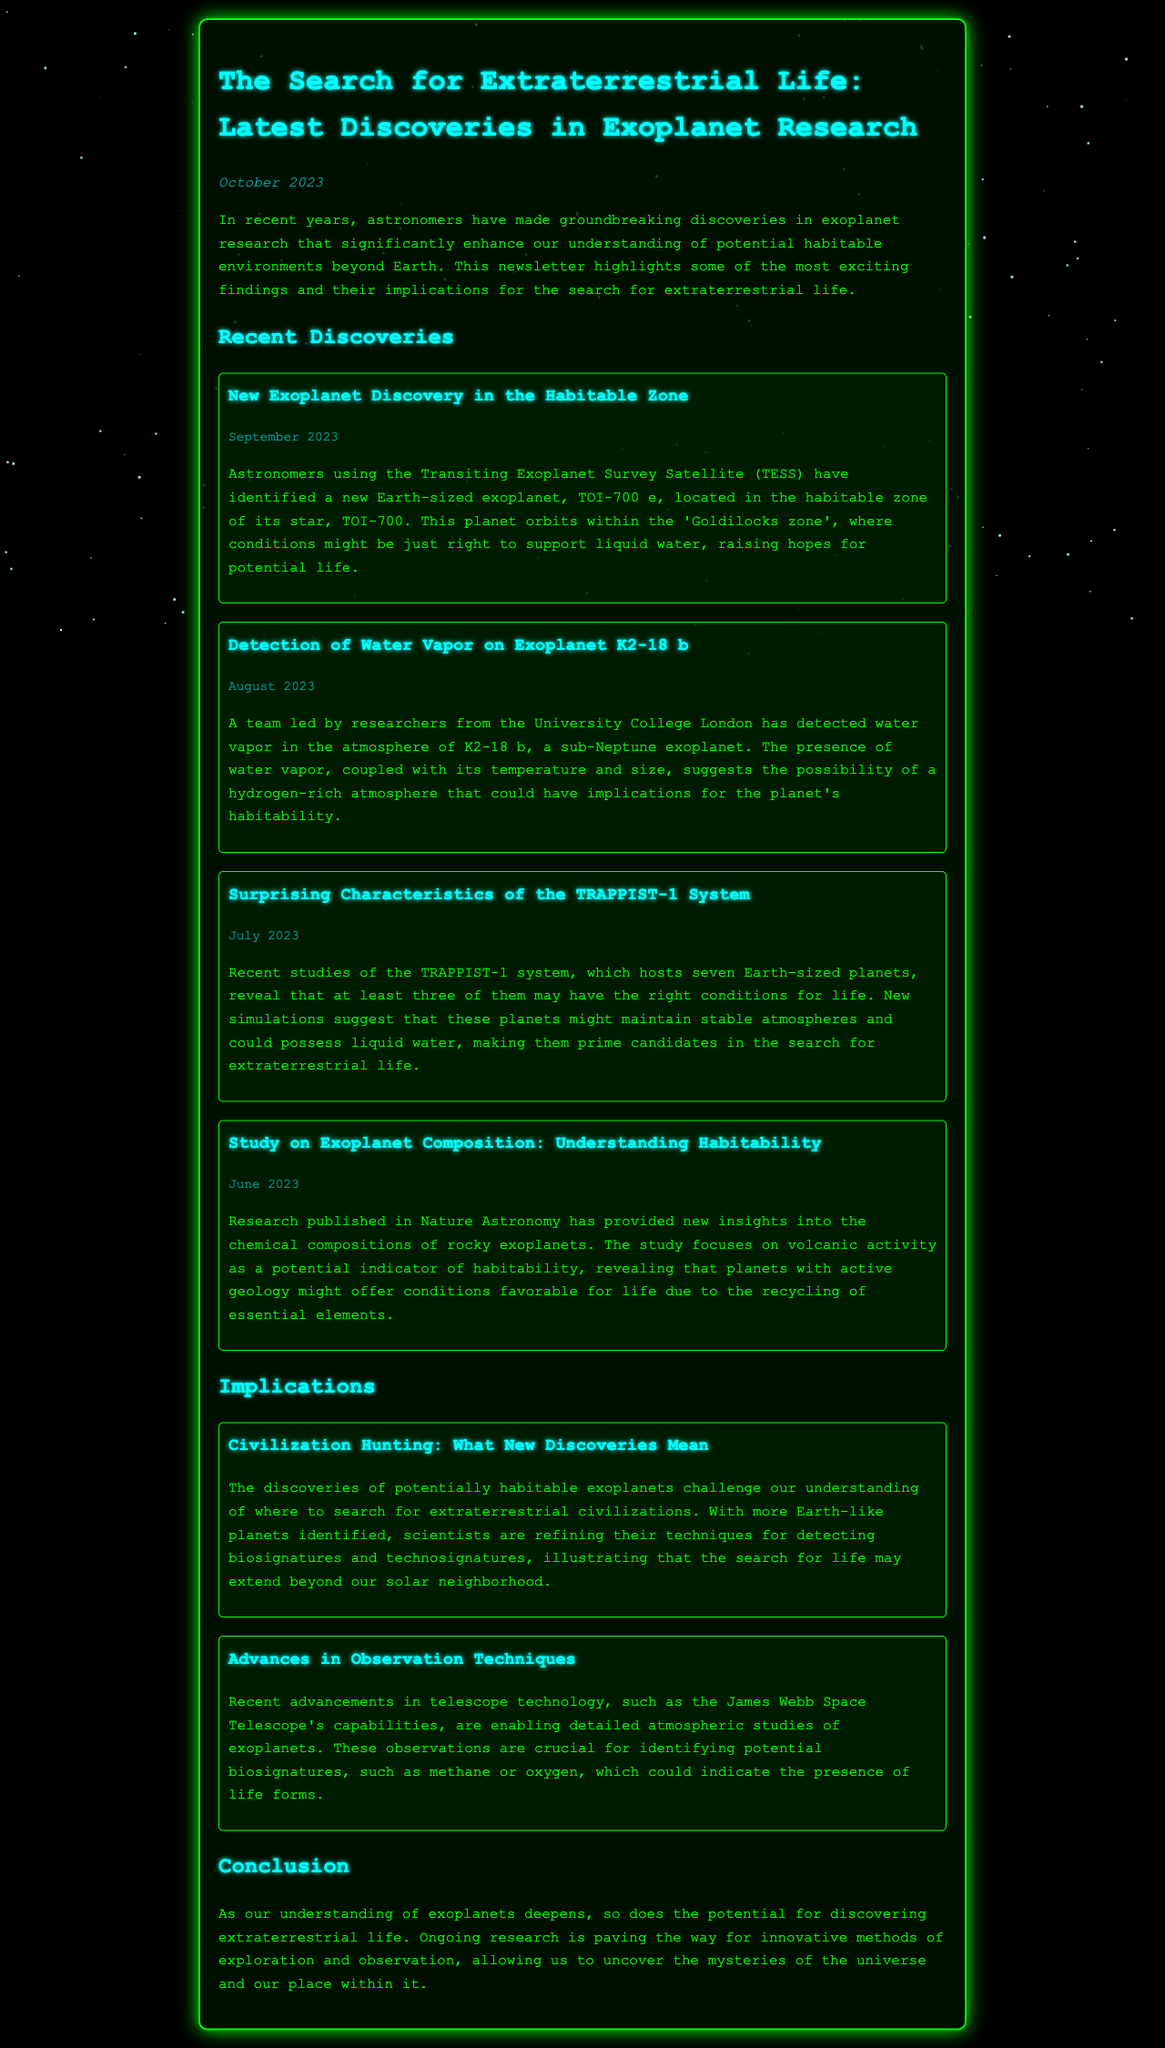what is the name of the new exoplanet discovered in September 2023? The document mentions that the new exoplanet discovered is TOI-700 e.
Answer: TOI-700 e when was water vapor detected on exoplanet K2-18 b? The document states that water vapor was detected on K2-18 b in August 2023.
Answer: August 2023 how many Earth-sized planets are in the TRAPPIST-1 system? According to the document, there are seven Earth-sized planets in the TRAPPIST-1 system.
Answer: seven what is the significance of volcanic activity in the study of exoplanets? The document explains that volcanic activity could indicate habitability by recycling essential elements.
Answer: recycling essential elements what are biosignatures? The document describes biosignatures as indicators, such as methane or oxygen, that could indicate the presence of life forms.
Answer: indicators of life how does the recent discovery of TOI-700 e affect the search for extraterrestrial life? The document suggests that TOI-700 e being in the habitable zone raises hopes for potential life, influencing where to search for life.
Answer: raises hopes for potential life what major telescope's advancements are mentioned in the document? The document refers to the James Webb Space Telescope’s capabilities for detailed atmospheric studies.
Answer: James Webb Space Telescope what is the purpose of identifying technosignatures? The document indicates that identifying technosignatures is part of refining search techniques for extraterrestrial civilizations.
Answer: refining search techniques 